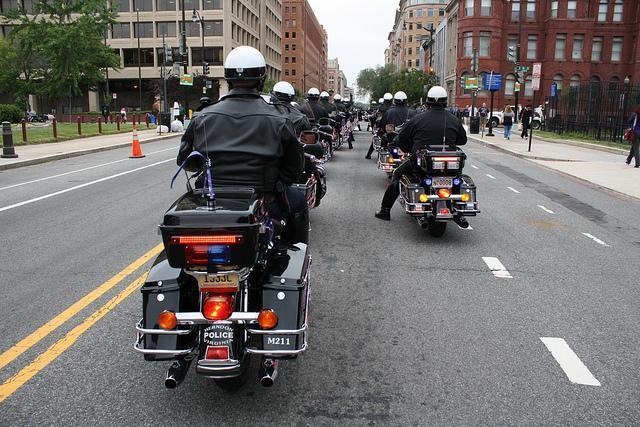How many people are there?
Give a very brief answer. 2. How many motorcycles can you see?
Give a very brief answer. 3. How many zebra near from tree?
Give a very brief answer. 0. 